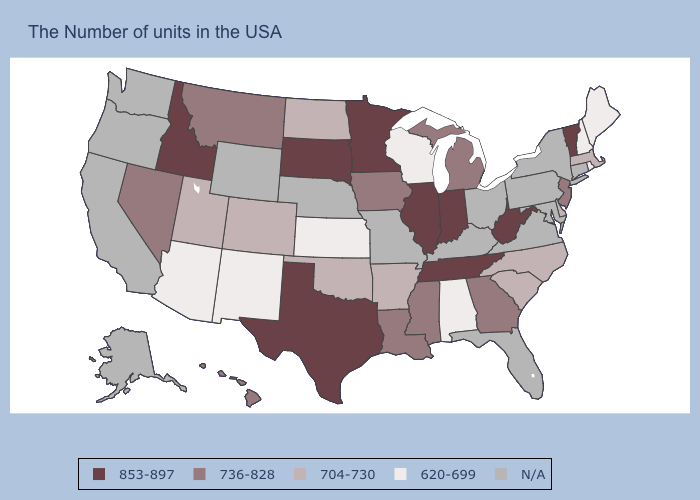What is the value of Massachusetts?
Quick response, please. 704-730. Does the map have missing data?
Write a very short answer. Yes. Name the states that have a value in the range 736-828?
Short answer required. New Jersey, Georgia, Michigan, Mississippi, Louisiana, Iowa, Montana, Nevada, Hawaii. What is the highest value in the USA?
Quick response, please. 853-897. Does the first symbol in the legend represent the smallest category?
Be succinct. No. Which states have the lowest value in the West?
Keep it brief. New Mexico, Arizona. Which states have the lowest value in the USA?
Answer briefly. Maine, Rhode Island, New Hampshire, Alabama, Wisconsin, Kansas, New Mexico, Arizona. Does North Dakota have the lowest value in the MidWest?
Keep it brief. No. What is the lowest value in states that border Oklahoma?
Quick response, please. 620-699. Name the states that have a value in the range 853-897?
Quick response, please. Vermont, West Virginia, Indiana, Tennessee, Illinois, Minnesota, Texas, South Dakota, Idaho. What is the value of New York?
Short answer required. N/A. Does Michigan have the lowest value in the USA?
Short answer required. No. 